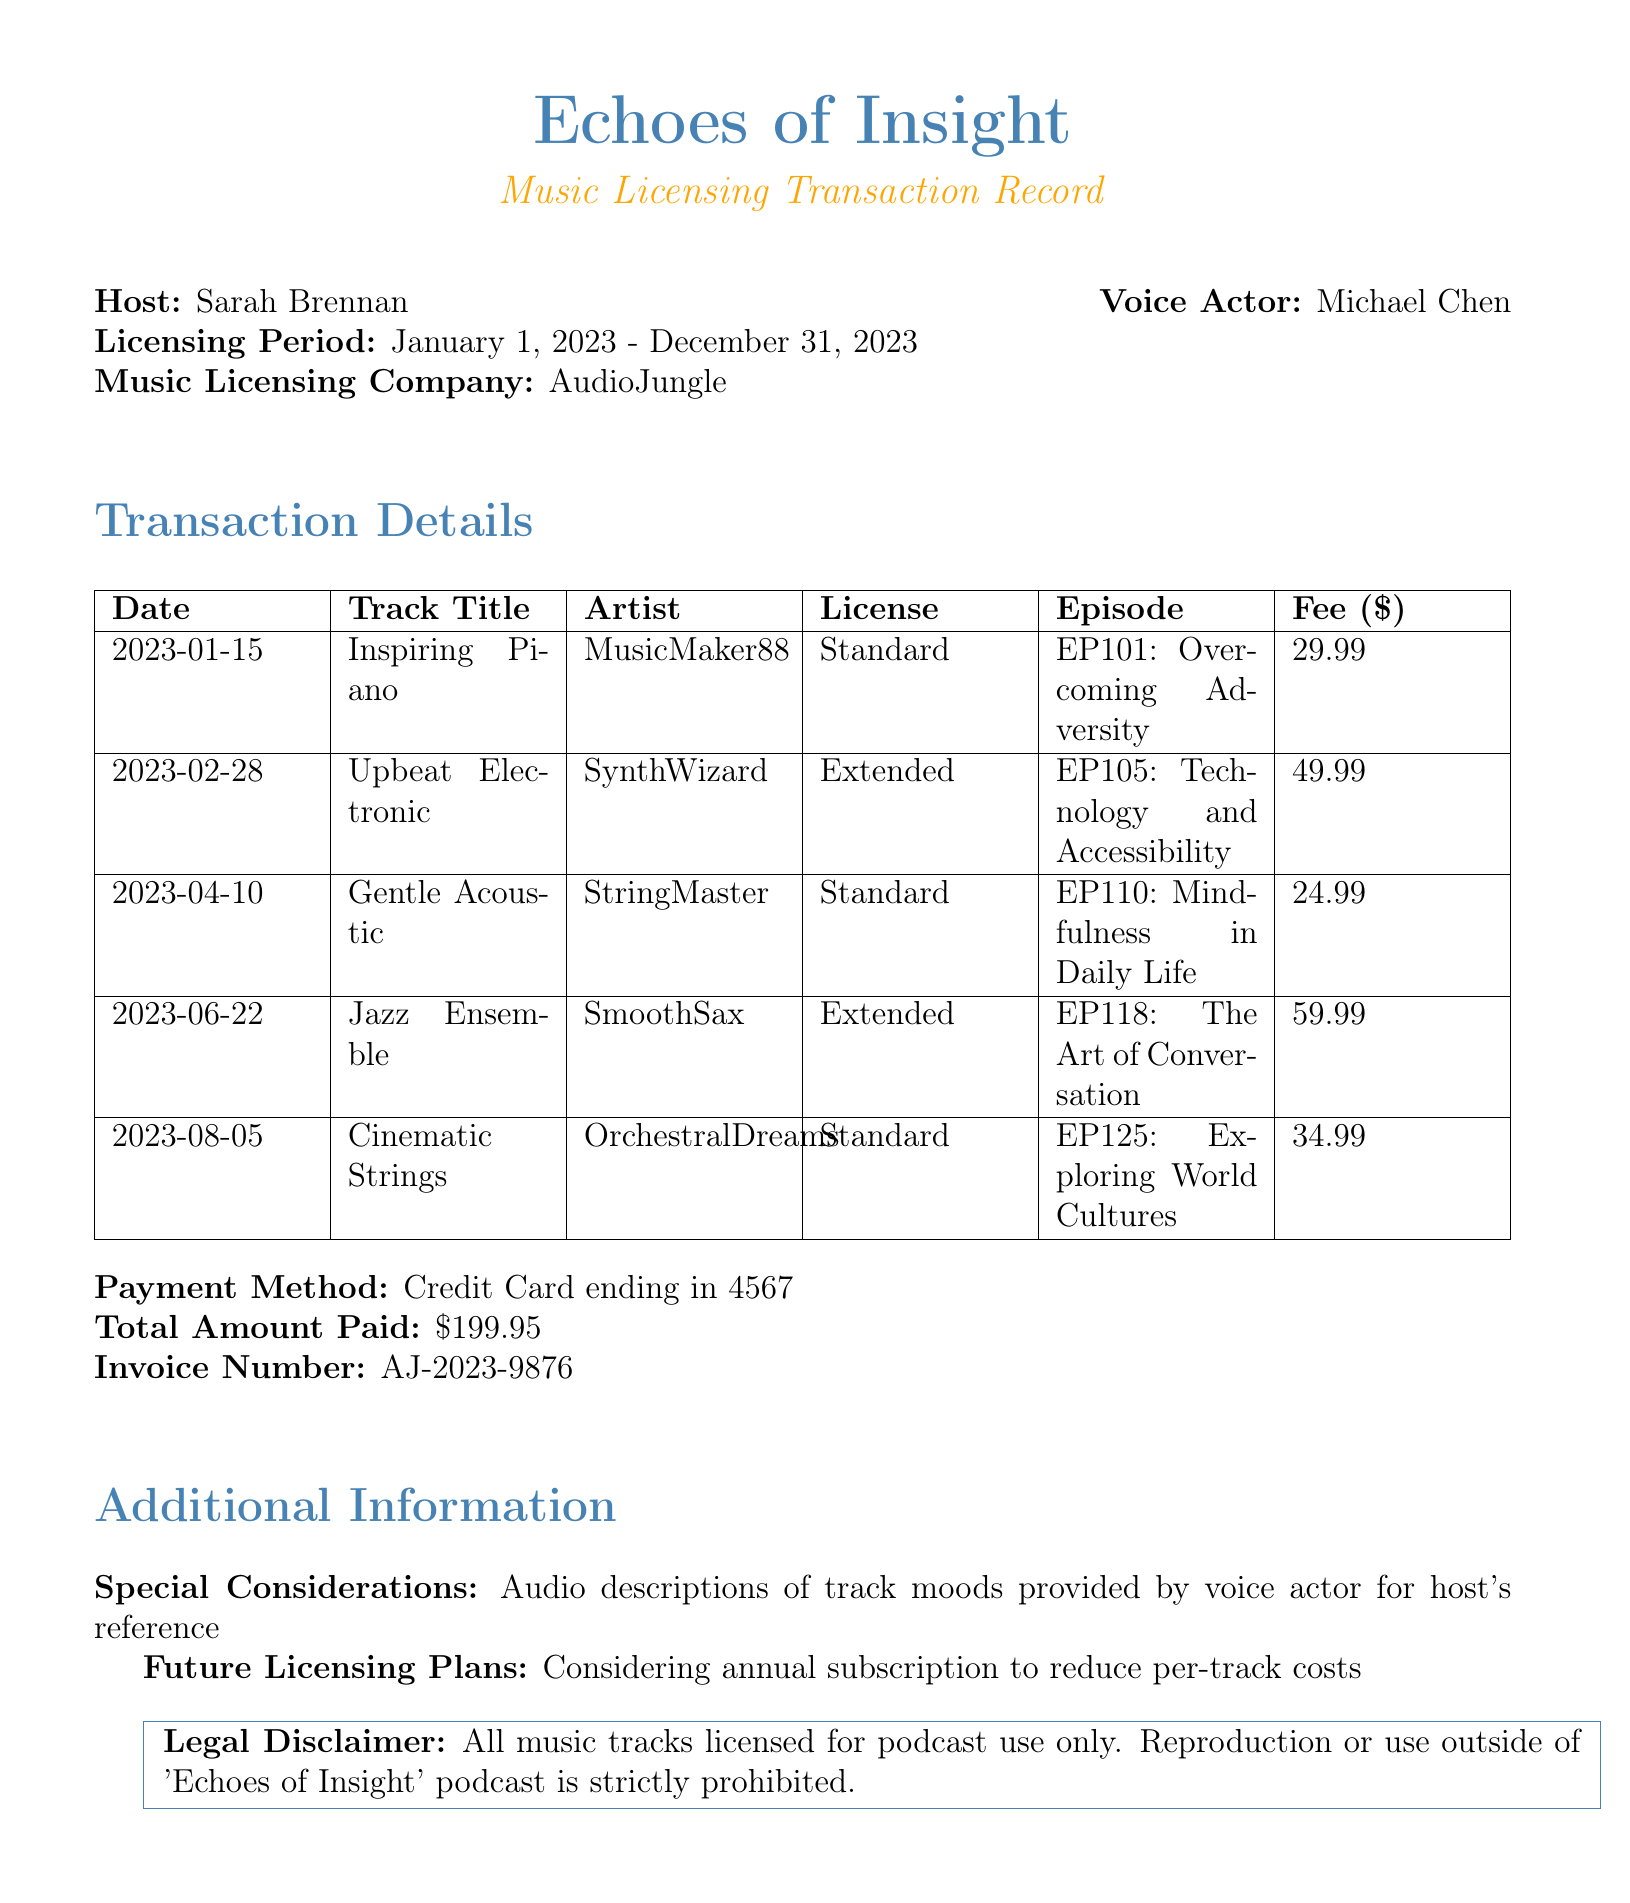What is the podcast name? The podcast name is stated at the top of the document.
Answer: Echoes of Insight Who is the host of the podcast? The host's name is mentioned in the header section of the document.
Answer: Sarah Brennan What is the total amount paid for licensing? The total amount paid is listed under the payment details section.
Answer: $199.95 On what date was the track "Upbeat Electronic" licensed? The date of licensing is provided within the transaction details.
Answer: 2023-02-28 What is the licensing period for the music used in the podcast? The licensing period is specified in the header of the document.
Answer: January 1, 2023 - December 31, 2023 How many tracks were licensed in the transaction? The number of tracks can be found by counting the entries in the transaction details.
Answer: 5 What is the invoice number associated with this transaction? The invoice number is explicitly mentioned in the payment details section.
Answer: AJ-2023-9876 Which payment method was used for the transaction? The payment method is provided in the transaction record.
Answer: Credit Card ending in 4567 What future licensing plans are mentioned in the document? The future licensing plans are described in the additional information section.
Answer: Considering annual subscription to reduce per-track costs 